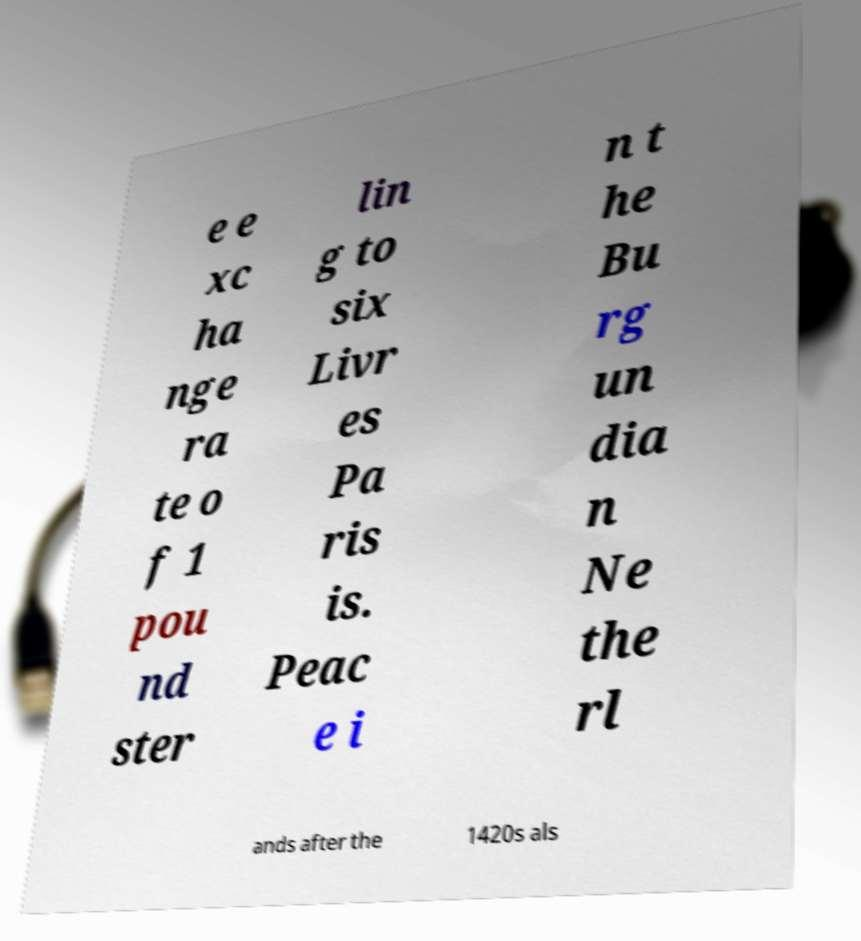Can you read and provide the text displayed in the image?This photo seems to have some interesting text. Can you extract and type it out for me? e e xc ha nge ra te o f 1 pou nd ster lin g to six Livr es Pa ris is. Peac e i n t he Bu rg un dia n Ne the rl ands after the 1420s als 